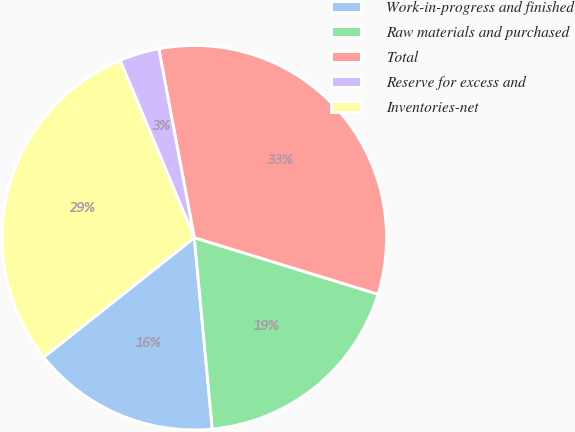<chart> <loc_0><loc_0><loc_500><loc_500><pie_chart><fcel>Work-in-progress and finished<fcel>Raw materials and purchased<fcel>Total<fcel>Reserve for excess and<fcel>Inventories-net<nl><fcel>15.82%<fcel>18.75%<fcel>32.71%<fcel>3.35%<fcel>29.36%<nl></chart> 